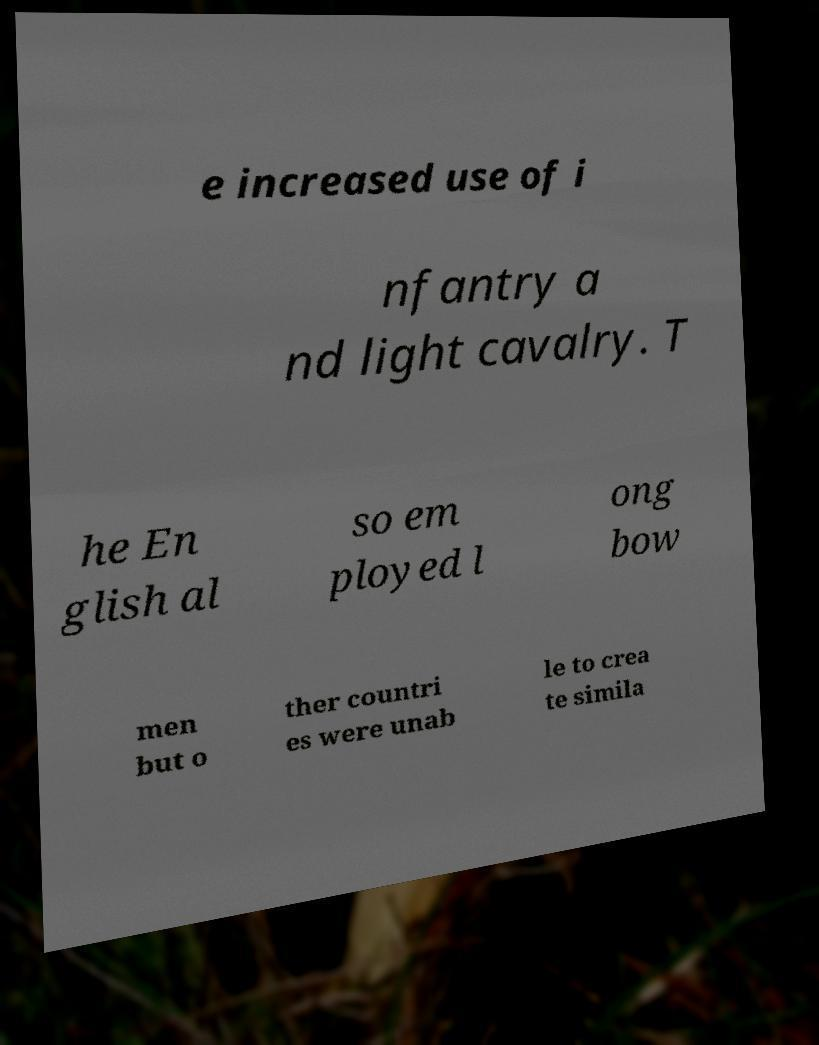I need the written content from this picture converted into text. Can you do that? e increased use of i nfantry a nd light cavalry. T he En glish al so em ployed l ong bow men but o ther countri es were unab le to crea te simila 